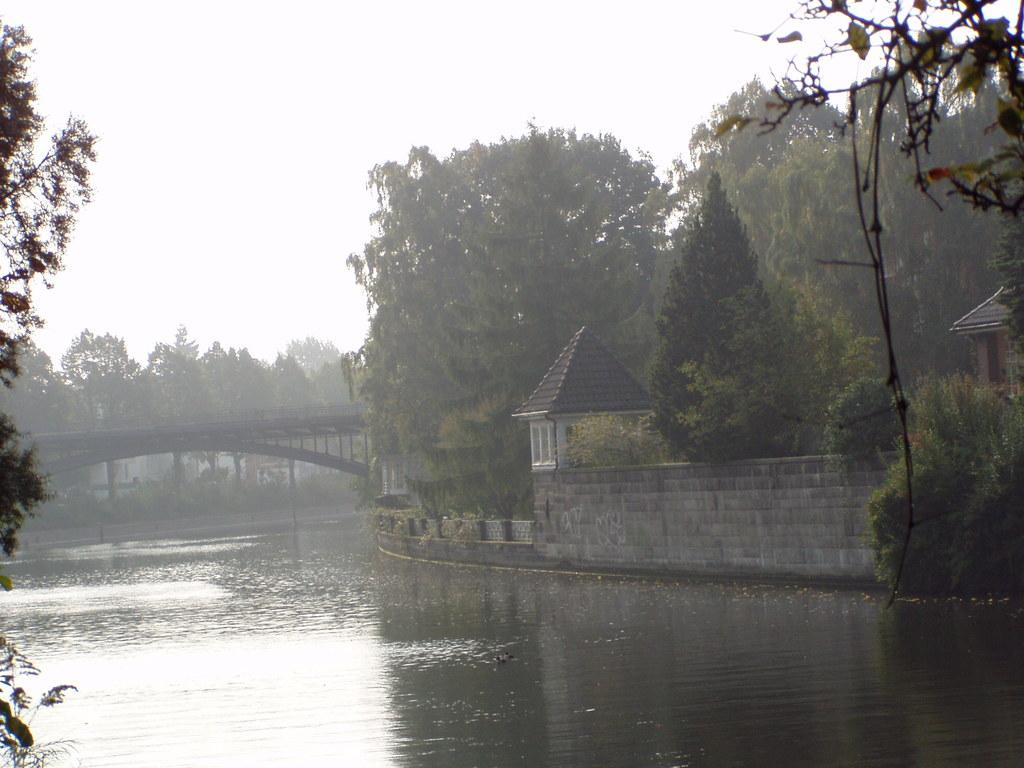What is one of the natural elements present in the image? There is water in the image. What type of vegetation can be seen in the image? There are trees in the image. What object is present that might be used for holding or serving food? There is a bowl in the image. What type of structures are visible in the image? There are houses in the image. What architectural feature is present in the image that allows people to cross the water? There is a bridge in the image. What part of the natural environment is visible in the image? The sky is visible in the image. How many plants are growing on the bridge in the image? There are no plants growing on the bridge in the image; it is a structure for crossing the water. What type of weather can be seen in the image? The provided facts do not mention any specific weather conditions, so it cannot be determined from the image. 